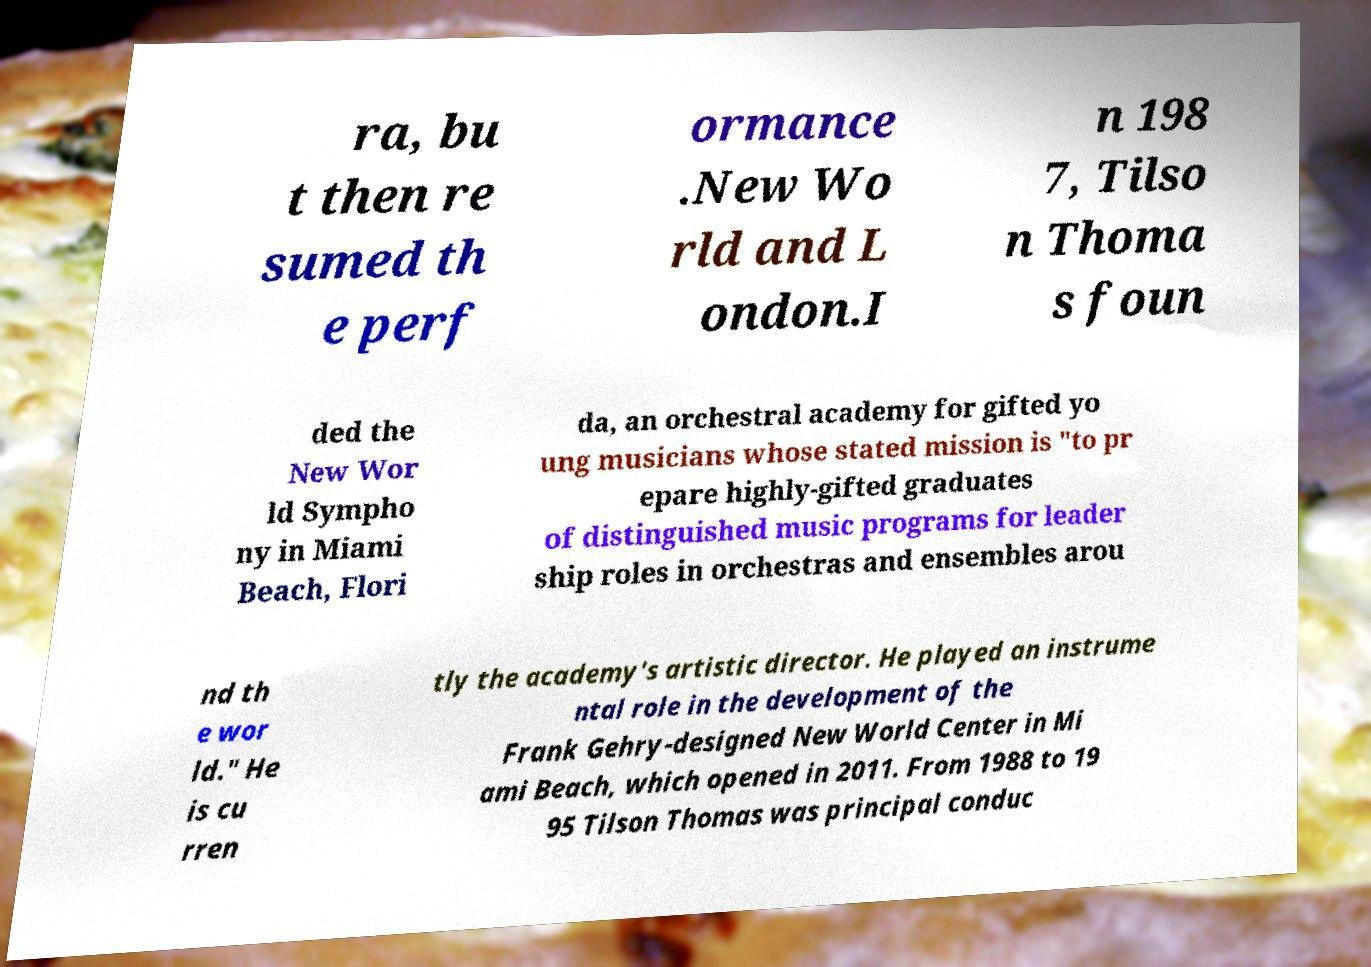What messages or text are displayed in this image? I need them in a readable, typed format. ra, bu t then re sumed th e perf ormance .New Wo rld and L ondon.I n 198 7, Tilso n Thoma s foun ded the New Wor ld Sympho ny in Miami Beach, Flori da, an orchestral academy for gifted yo ung musicians whose stated mission is "to pr epare highly-gifted graduates of distinguished music programs for leader ship roles in orchestras and ensembles arou nd th e wor ld." He is cu rren tly the academy's artistic director. He played an instrume ntal role in the development of the Frank Gehry-designed New World Center in Mi ami Beach, which opened in 2011. From 1988 to 19 95 Tilson Thomas was principal conduc 